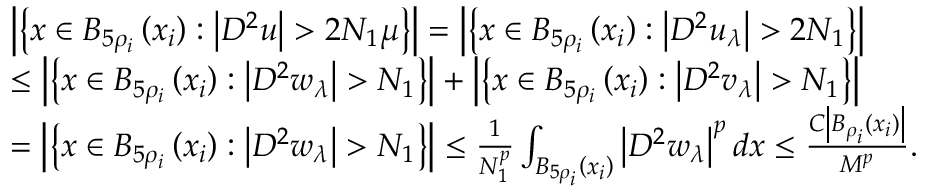<formula> <loc_0><loc_0><loc_500><loc_500>\begin{array} { r l } & { \left | \left \{ x \in B _ { 5 \rho _ { i } } \left ( x _ { i } \right ) \colon \left | D ^ { 2 } u \right | > 2 N _ { 1 } \mu \right \} \right | = \left | \left \{ x \in B _ { 5 \rho _ { i } } \left ( x _ { i } \right ) \colon \left | D ^ { 2 } u _ { \lambda } \right | > 2 N _ { 1 } \right \} \right | } \\ & { \leq \left | \left \{ x \in B _ { 5 \rho _ { i } } \left ( x _ { i } \right ) \colon \left | D ^ { 2 } w _ { \lambda } \right | > N _ { 1 } \right \} \right | + \left | \left \{ x \in B _ { 5 \rho _ { i } } \left ( x _ { i } \right ) \colon \left | D ^ { 2 } v _ { \lambda } \right | > N _ { 1 } \right \} \right | } \\ & { = \left | \left \{ x \in B _ { 5 \rho _ { i } } \left ( x _ { i } \right ) \colon \left | D ^ { 2 } w _ { \lambda } \right | > N _ { 1 } \right \} \right | \leq \frac { 1 } { N _ { 1 } ^ { p } } \int _ { B _ { 5 \rho _ { i } } \left ( x _ { i } \right ) } \left | D ^ { 2 } w _ { \lambda } \right | ^ { p } d x \leq \frac { C \left | B _ { \rho _ { i } } \left ( x _ { i } \right ) \right | } { M ^ { p } } . } \end{array}</formula> 